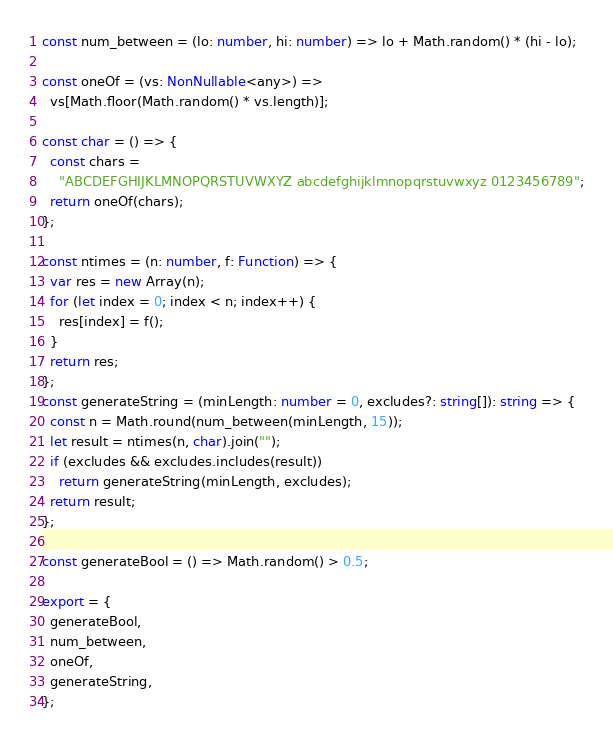<code> <loc_0><loc_0><loc_500><loc_500><_TypeScript_>const num_between = (lo: number, hi: number) => lo + Math.random() * (hi - lo);

const oneOf = (vs: NonNullable<any>) =>
  vs[Math.floor(Math.random() * vs.length)];

const char = () => {
  const chars =
    "ABCDEFGHIJKLMNOPQRSTUVWXYZ abcdefghijklmnopqrstuvwxyz 0123456789";
  return oneOf(chars);
};

const ntimes = (n: number, f: Function) => {
  var res = new Array(n);
  for (let index = 0; index < n; index++) {
    res[index] = f();
  }
  return res;
};
const generateString = (minLength: number = 0, excludes?: string[]): string => {
  const n = Math.round(num_between(minLength, 15));
  let result = ntimes(n, char).join("");
  if (excludes && excludes.includes(result))
    return generateString(minLength, excludes);
  return result;
};

const generateBool = () => Math.random() > 0.5;

export = {
  generateBool,
  num_between,
  oneOf,
  generateString,
};
</code> 